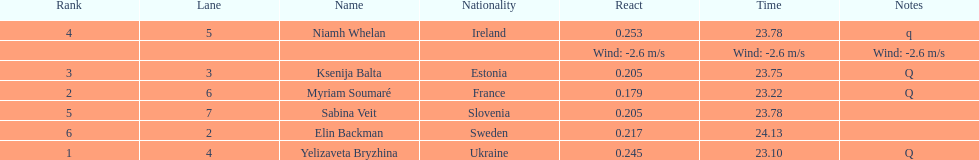The difference between yelizaveta bryzhina's time and ksenija balta's time? 0.65. 